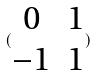<formula> <loc_0><loc_0><loc_500><loc_500>( \begin{matrix} 0 & 1 \\ - 1 & 1 \end{matrix} )</formula> 